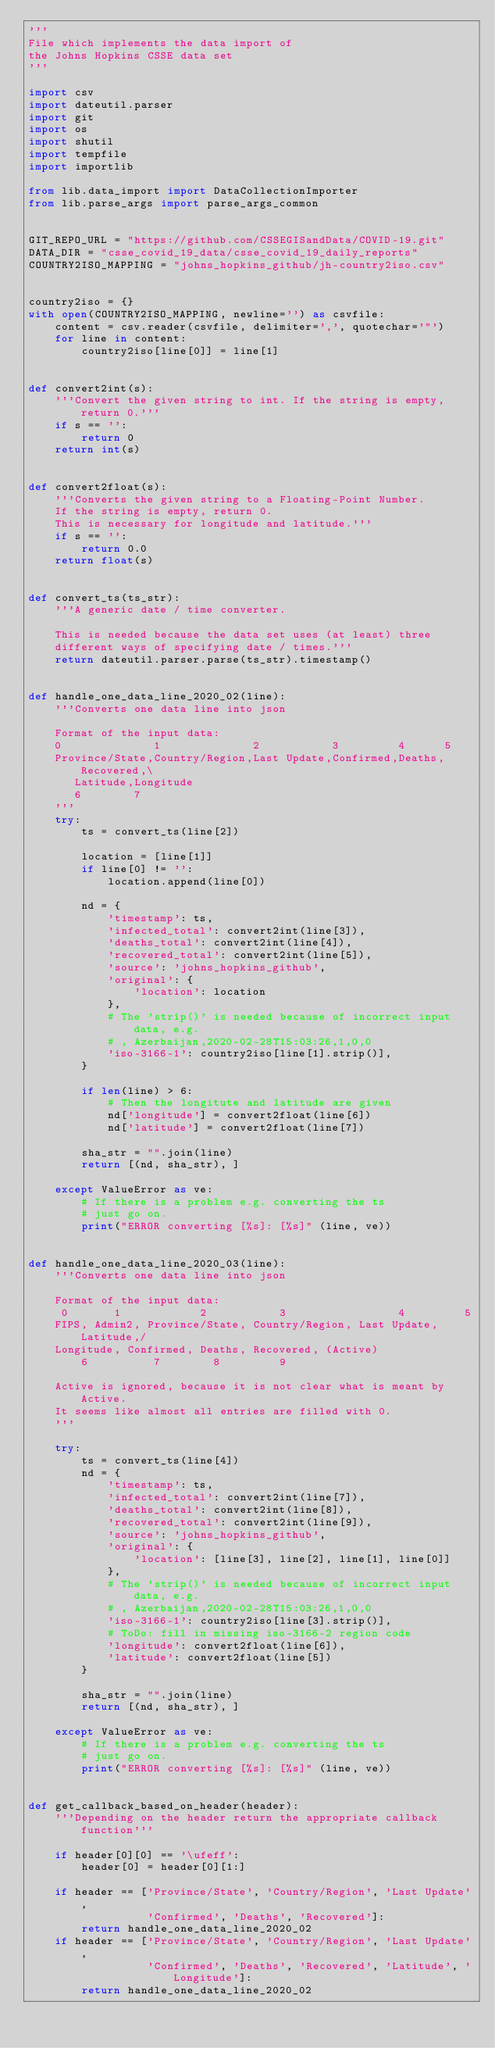<code> <loc_0><loc_0><loc_500><loc_500><_Python_>'''
File which implements the data import of
the Johns Hopkins CSSE data set
'''

import csv
import dateutil.parser
import git
import os
import shutil
import tempfile
import importlib

from lib.data_import import DataCollectionImporter
from lib.parse_args import parse_args_common


GIT_REPO_URL = "https://github.com/CSSEGISandData/COVID-19.git"
DATA_DIR = "csse_covid_19_data/csse_covid_19_daily_reports"
COUNTRY2ISO_MAPPING = "johns_hopkins_github/jh-country2iso.csv"


country2iso = {}
with open(COUNTRY2ISO_MAPPING, newline='') as csvfile:
    content = csv.reader(csvfile, delimiter=',', quotechar='"')
    for line in content:
        country2iso[line[0]] = line[1]


def convert2int(s):
    '''Convert the given string to int. If the string is empty, return 0.'''
    if s == '':
        return 0
    return int(s)


def convert2float(s):
    '''Converts the given string to a Floating-Point Number.
    If the string is empty, return 0.
    This is necessary for longitude and latitude.'''
    if s == '':
        return 0.0
    return float(s)


def convert_ts(ts_str):
    '''A generic date / time converter.

    This is needed because the data set uses (at least) three
    different ways of specifying date / times.'''
    return dateutil.parser.parse(ts_str).timestamp()


def handle_one_data_line_2020_02(line):
    '''Converts one data line into json

    Format of the input data:
    0              1              2           3         4      5
    Province/State,Country/Region,Last Update,Confirmed,Deaths,Recovered,\
       Latitude,Longitude
       6        7
    '''
    try:
        ts = convert_ts(line[2])

        location = [line[1]]
        if line[0] != '':
            location.append(line[0])

        nd = {
            'timestamp': ts,
            'infected_total': convert2int(line[3]),
            'deaths_total': convert2int(line[4]),
            'recovered_total': convert2int(line[5]),
            'source': 'johns_hopkins_github',
            'original': {
                'location': location
            },
            # The 'strip()' is needed because of incorrect input data, e.g.
            # , Azerbaijan,2020-02-28T15:03:26,1,0,0
            'iso-3166-1': country2iso[line[1].strip()],
        }

        if len(line) > 6:
            # Then the longitute and latitude are given
            nd['longitude'] = convert2float(line[6])
            nd['latitude'] = convert2float(line[7])

        sha_str = "".join(line)
        return [(nd, sha_str), ]

    except ValueError as ve:
        # If there is a problem e.g. converting the ts
        # just go on.
        print("ERROR converting [%s]: [%s]" (line, ve))


def handle_one_data_line_2020_03(line):
    '''Converts one data line into json

    Format of the input data:
     0       1            2           3                 4         5
    FIPS, Admin2, Province/State, Country/Region, Last Update, Latitude,/
    Longitude, Confirmed, Deaths, Recovered, (Active)
        6          7        8         9

    Active is ignored, because it is not clear what is meant by Active.
    It seems like almost all entries are filled with 0.
    '''

    try:
        ts = convert_ts(line[4])
        nd = {
            'timestamp': ts,
            'infected_total': convert2int(line[7]),
            'deaths_total': convert2int(line[8]),
            'recovered_total': convert2int(line[9]),
            'source': 'johns_hopkins_github',
            'original': {
                'location': [line[3], line[2], line[1], line[0]]
            },
            # The 'strip()' is needed because of incorrect input data, e.g.
            # , Azerbaijan,2020-02-28T15:03:26,1,0,0
            'iso-3166-1': country2iso[line[3].strip()],
            # ToDo: fill in missing iso-3166-2 region code
            'longitude': convert2float(line[6]),
            'latitude': convert2float(line[5])
        }

        sha_str = "".join(line)
        return [(nd, sha_str), ]

    except ValueError as ve:
        # If there is a problem e.g. converting the ts
        # just go on.
        print("ERROR converting [%s]: [%s]" (line, ve))


def get_callback_based_on_header(header):
    '''Depending on the header return the appropriate callback function'''

    if header[0][0] == '\ufeff':
        header[0] = header[0][1:]

    if header == ['Province/State', 'Country/Region', 'Last Update',
                  'Confirmed', 'Deaths', 'Recovered']:
        return handle_one_data_line_2020_02
    if header == ['Province/State', 'Country/Region', 'Last Update',
                  'Confirmed', 'Deaths', 'Recovered', 'Latitude', 'Longitude']:
        return handle_one_data_line_2020_02
</code> 